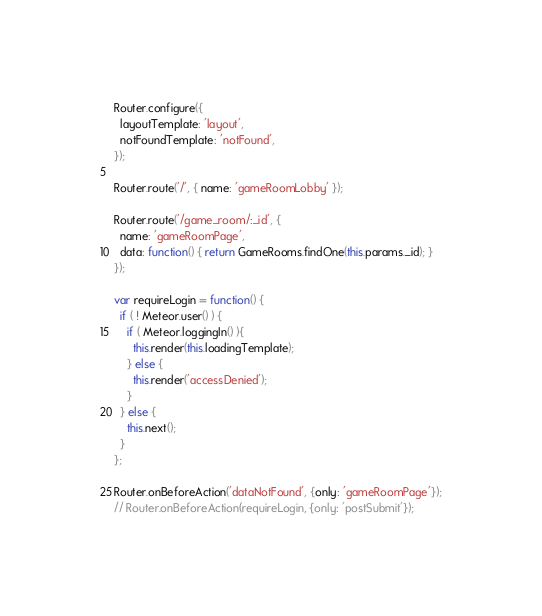Convert code to text. <code><loc_0><loc_0><loc_500><loc_500><_JavaScript_>Router.configure({
  layoutTemplate: 'layout',
  notFoundTemplate: 'notFound',
});

Router.route('/', { name: 'gameRoomLobby' });

Router.route('/game_room/:_id', {
  name: 'gameRoomPage',
  data: function() { return GameRooms.findOne(this.params._id); }
});

var requireLogin = function() {
  if ( ! Meteor.user() ) {
    if ( Meteor.loggingIn() ){
      this.render(this.loadingTemplate);
    } else {
      this.render('accessDenied');
    }
  } else {
    this.next();
  }
};

Router.onBeforeAction('dataNotFound', {only: 'gameRoomPage'});
// Router.onBeforeAction(requireLogin, {only: 'postSubmit'});

</code> 